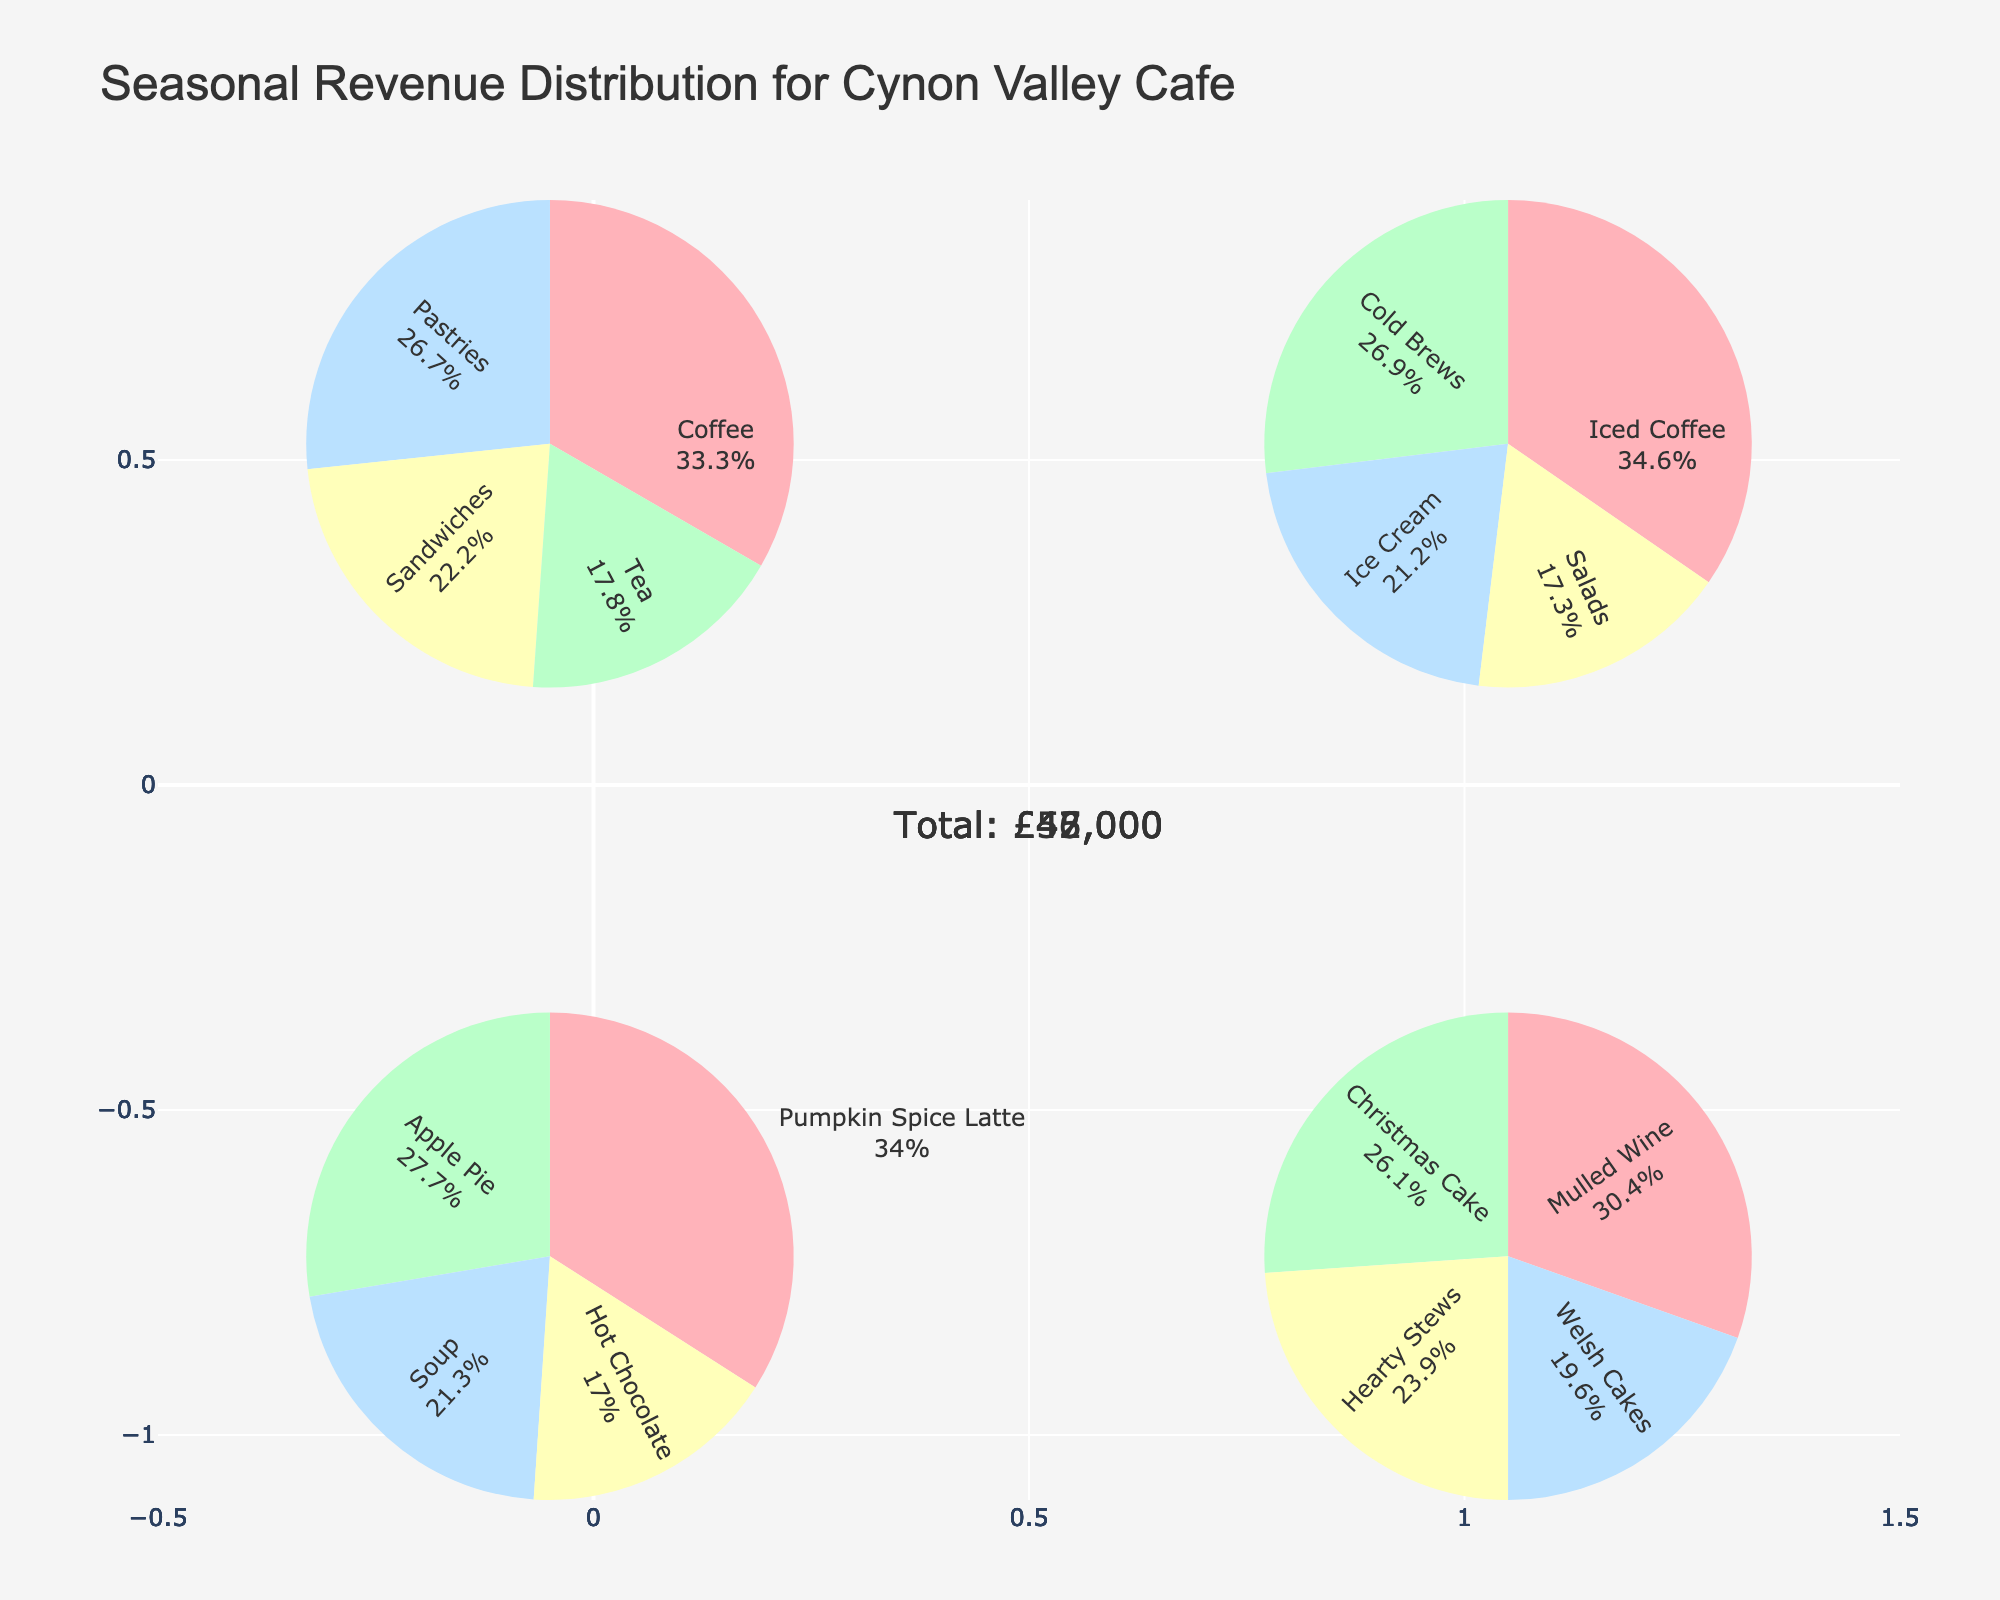What's the title of the figure? The title is usually found at the top of the figure. In this case, it reads "Seasonal Revenue Distribution for Cynon Valley Cafe".
Answer: Seasonal Revenue Distribution for Cynon Valley Cafe How many seasons are represented in the figure? The subplot has four pie charts, each corresponding to a different season as indicated in the subplot titles.
Answer: Four Which season has the highest single item revenue, and what is it? By looking at the proportions in the pie charts, the "Iced Coffee" slice in Summer seems to be the largest. The hover information would confirm it at 18,000.
Answer: Summer, 18,000 What is the revenue distribution for coffee products in Spring? The pie chart for Spring shows the revenue distribution. Coffee has a label indicating both the percentage and value, reflected as "15,000" in the pie chart hover info.
Answer: 15,000 Which season has the lowest overall revenue and what is the total amount? Each chart has annotations indicating the total revenue for that season. Comparatively, Winter has the lowest total revenue which is derived from summing up the individual items.
Answer: Winter Compare the revenue from "Apple Pie" in Autumn and "Christmas Cake" in Winter. Which is higher? Look at the pie charts for Autumn and Winter, respectively. "Apple Pie" has 13,000 and "Christmas Cake" has 12,000 as indicated in their labels.
Answer: Apple Pie How does the revenue from "Hearty Stews" in Winter compare to "Sandwiches" in Spring? By comparing the revenue from "Hearty Stews" in Winter (11,000) to "Sandwiches" in Spring (10,000) from their respective pie slices.
Answer: Hearty Stews is higher What's the average revenue earned from "Cold Brews" and "Ice Cream" in Summer? Summing up the revenue from "Cold Brews" (14,000) and "Ice Cream" (11,000) and dividing by the number of items (2), gives (14,000 + 11,000)/2 = 12,500.
Answer: 12,500 What percentage of Spring's total revenue comes from "Pastries"? The pie chart for Spring's "Pastries" shows the percentage directly, calculated based on the slice size.
Answer: Look at the label's percentage In which season does the lowest revenue-generating item appear, and what is the revenue? By scanning the pie charts, "Hot Chocolate" in Autumn has the smallest slice at 8,000.
Answer: Autumn, 8,000 